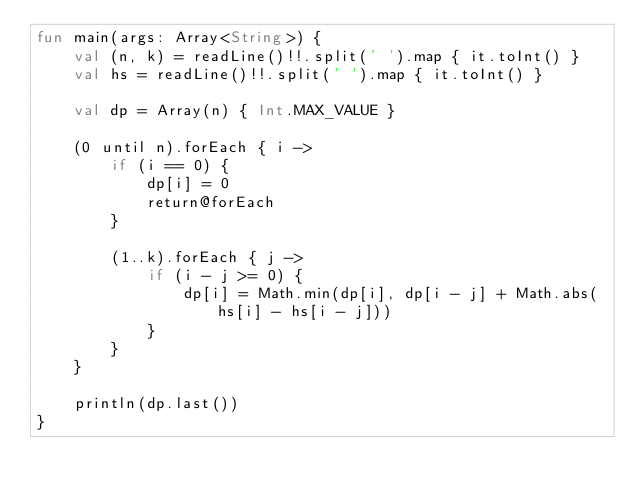<code> <loc_0><loc_0><loc_500><loc_500><_Kotlin_>fun main(args: Array<String>) {
    val (n, k) = readLine()!!.split(' ').map { it.toInt() }
    val hs = readLine()!!.split(' ').map { it.toInt() }

    val dp = Array(n) { Int.MAX_VALUE }

    (0 until n).forEach { i ->
        if (i == 0) {
            dp[i] = 0
            return@forEach
        }

        (1..k).forEach { j ->
            if (i - j >= 0) {
                dp[i] = Math.min(dp[i], dp[i - j] + Math.abs(hs[i] - hs[i - j]))
            }
        }
    }

    println(dp.last())
}</code> 